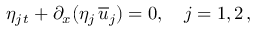Convert formula to latex. <formula><loc_0><loc_0><loc_500><loc_500>\eta _ { j \, t } + \partial _ { x } ( \eta _ { j } \, { \overline { u } } _ { j } ) = 0 , \quad j = 1 , 2 \, ,</formula> 